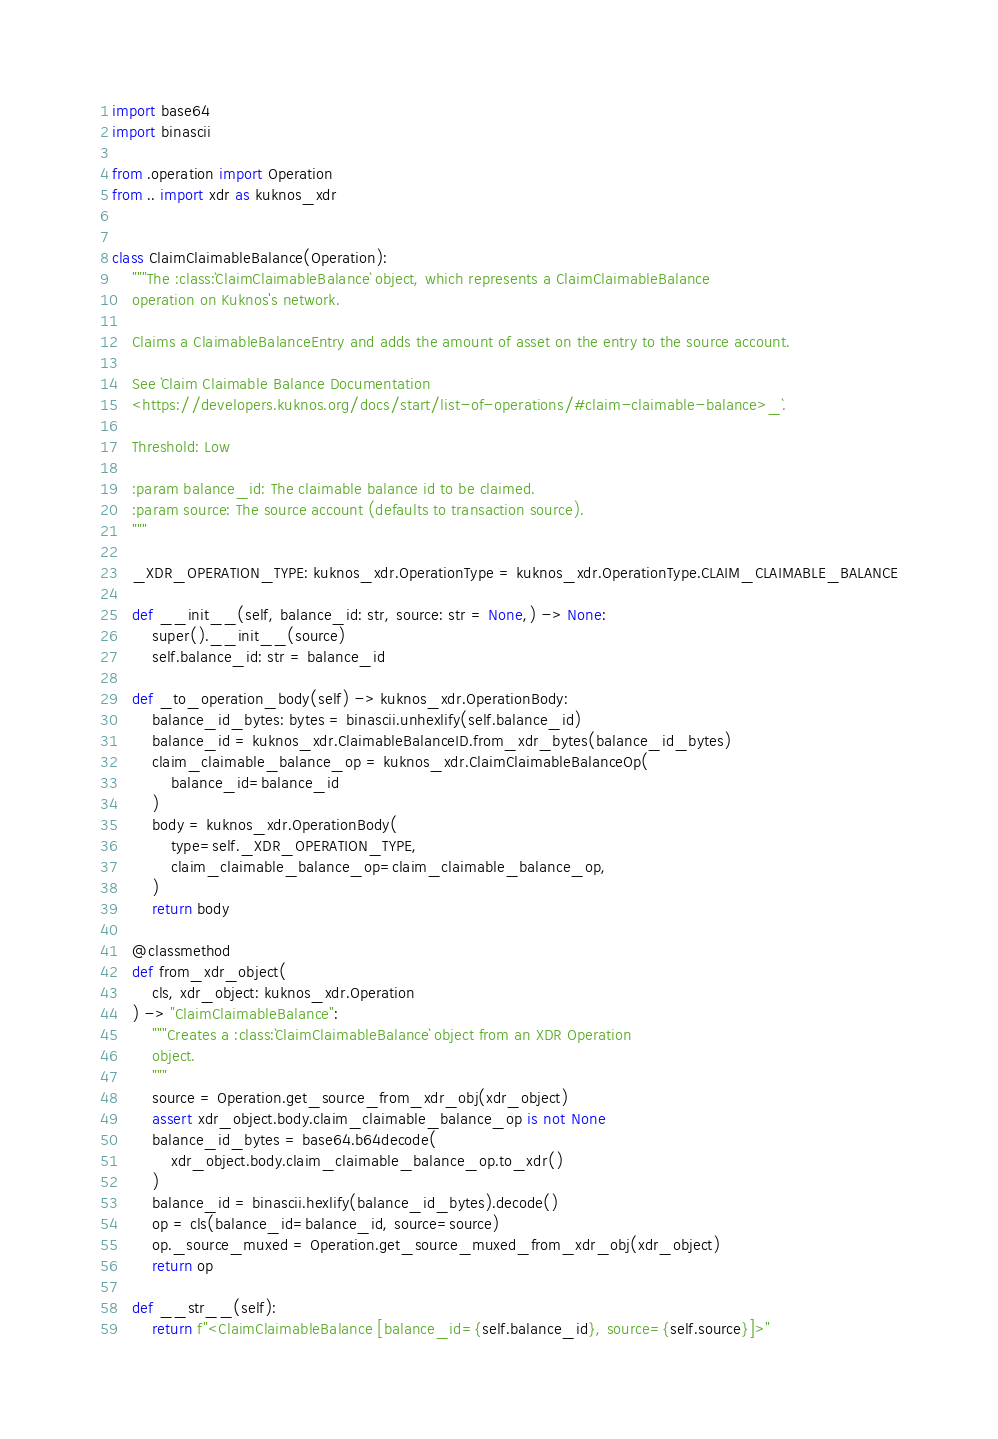<code> <loc_0><loc_0><loc_500><loc_500><_Python_>import base64
import binascii

from .operation import Operation
from .. import xdr as kuknos_xdr


class ClaimClaimableBalance(Operation):
    """The :class:`ClaimClaimableBalance` object, which represents a ClaimClaimableBalance
    operation on Kuknos's network.

    Claims a ClaimableBalanceEntry and adds the amount of asset on the entry to the source account.

    See `Claim Claimable Balance Documentation
    <https://developers.kuknos.org/docs/start/list-of-operations/#claim-claimable-balance>_`.

    Threshold: Low

    :param balance_id: The claimable balance id to be claimed.
    :param source: The source account (defaults to transaction source).
    """

    _XDR_OPERATION_TYPE: kuknos_xdr.OperationType = kuknos_xdr.OperationType.CLAIM_CLAIMABLE_BALANCE

    def __init__(self, balance_id: str, source: str = None,) -> None:
        super().__init__(source)
        self.balance_id: str = balance_id

    def _to_operation_body(self) -> kuknos_xdr.OperationBody:
        balance_id_bytes: bytes = binascii.unhexlify(self.balance_id)
        balance_id = kuknos_xdr.ClaimableBalanceID.from_xdr_bytes(balance_id_bytes)
        claim_claimable_balance_op = kuknos_xdr.ClaimClaimableBalanceOp(
            balance_id=balance_id
        )
        body = kuknos_xdr.OperationBody(
            type=self._XDR_OPERATION_TYPE,
            claim_claimable_balance_op=claim_claimable_balance_op,
        )
        return body

    @classmethod
    def from_xdr_object(
        cls, xdr_object: kuknos_xdr.Operation
    ) -> "ClaimClaimableBalance":
        """Creates a :class:`ClaimClaimableBalance` object from an XDR Operation
        object.
        """
        source = Operation.get_source_from_xdr_obj(xdr_object)
        assert xdr_object.body.claim_claimable_balance_op is not None
        balance_id_bytes = base64.b64decode(
            xdr_object.body.claim_claimable_balance_op.to_xdr()
        )
        balance_id = binascii.hexlify(balance_id_bytes).decode()
        op = cls(balance_id=balance_id, source=source)
        op._source_muxed = Operation.get_source_muxed_from_xdr_obj(xdr_object)
        return op

    def __str__(self):
        return f"<ClaimClaimableBalance [balance_id={self.balance_id}, source={self.source}]>"
</code> 